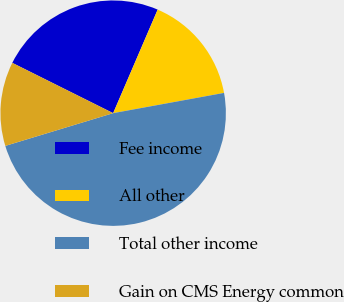Convert chart. <chart><loc_0><loc_0><loc_500><loc_500><pie_chart><fcel>Fee income<fcel>All other<fcel>Total other income<fcel>Gain on CMS Energy common<nl><fcel>24.1%<fcel>15.66%<fcel>48.19%<fcel>12.05%<nl></chart> 